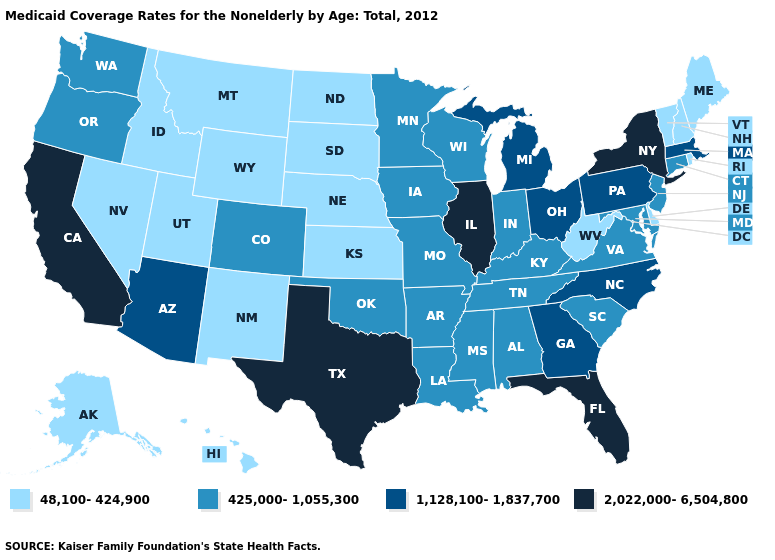Does the map have missing data?
Concise answer only. No. Which states have the highest value in the USA?
Concise answer only. California, Florida, Illinois, New York, Texas. What is the lowest value in the MidWest?
Quick response, please. 48,100-424,900. Name the states that have a value in the range 2,022,000-6,504,800?
Quick response, please. California, Florida, Illinois, New York, Texas. Name the states that have a value in the range 1,128,100-1,837,700?
Give a very brief answer. Arizona, Georgia, Massachusetts, Michigan, North Carolina, Ohio, Pennsylvania. What is the lowest value in the MidWest?
Give a very brief answer. 48,100-424,900. What is the value of Arizona?
Concise answer only. 1,128,100-1,837,700. Name the states that have a value in the range 1,128,100-1,837,700?
Answer briefly. Arizona, Georgia, Massachusetts, Michigan, North Carolina, Ohio, Pennsylvania. Which states have the lowest value in the West?
Short answer required. Alaska, Hawaii, Idaho, Montana, Nevada, New Mexico, Utah, Wyoming. What is the value of Michigan?
Short answer required. 1,128,100-1,837,700. Which states have the lowest value in the South?
Give a very brief answer. Delaware, West Virginia. Which states hav the highest value in the West?
Concise answer only. California. Does the first symbol in the legend represent the smallest category?
Write a very short answer. Yes. What is the highest value in states that border Iowa?
Quick response, please. 2,022,000-6,504,800. 